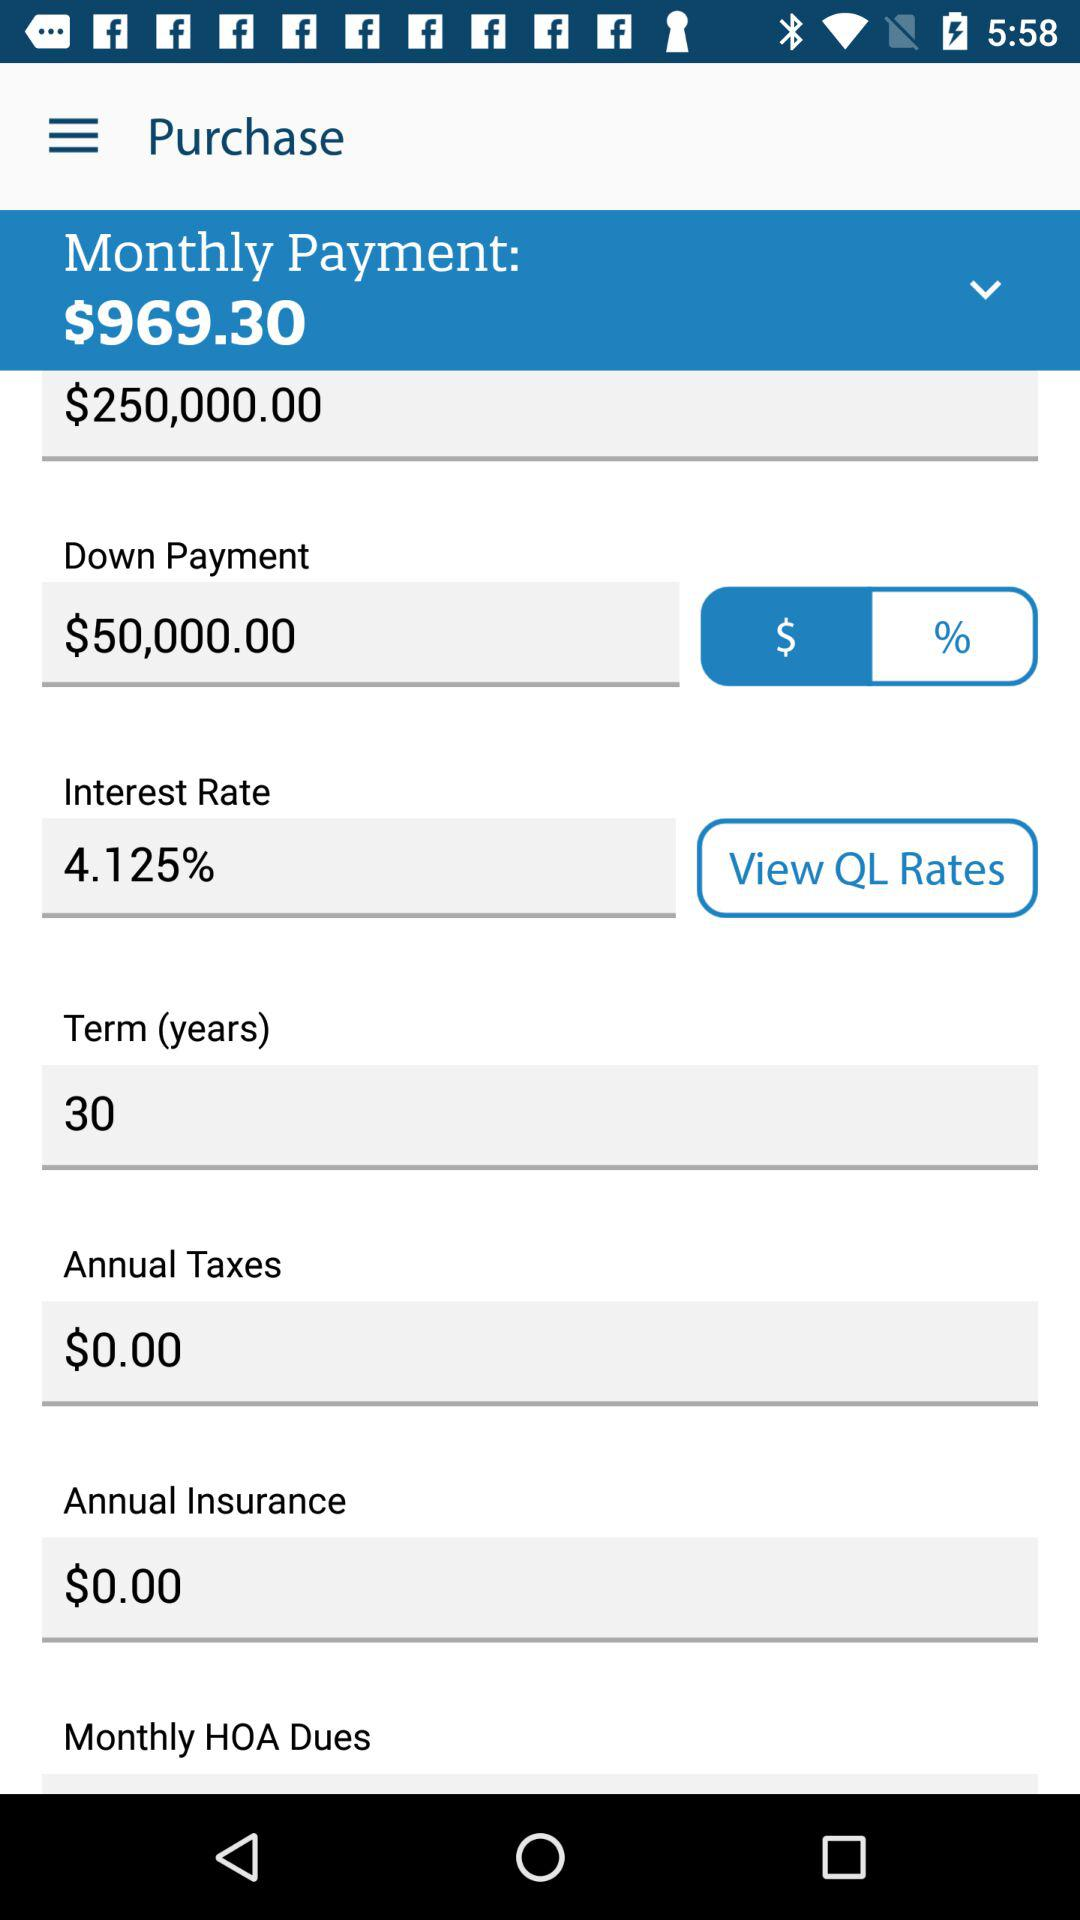What is the down payment? The down payment is $50,000. 